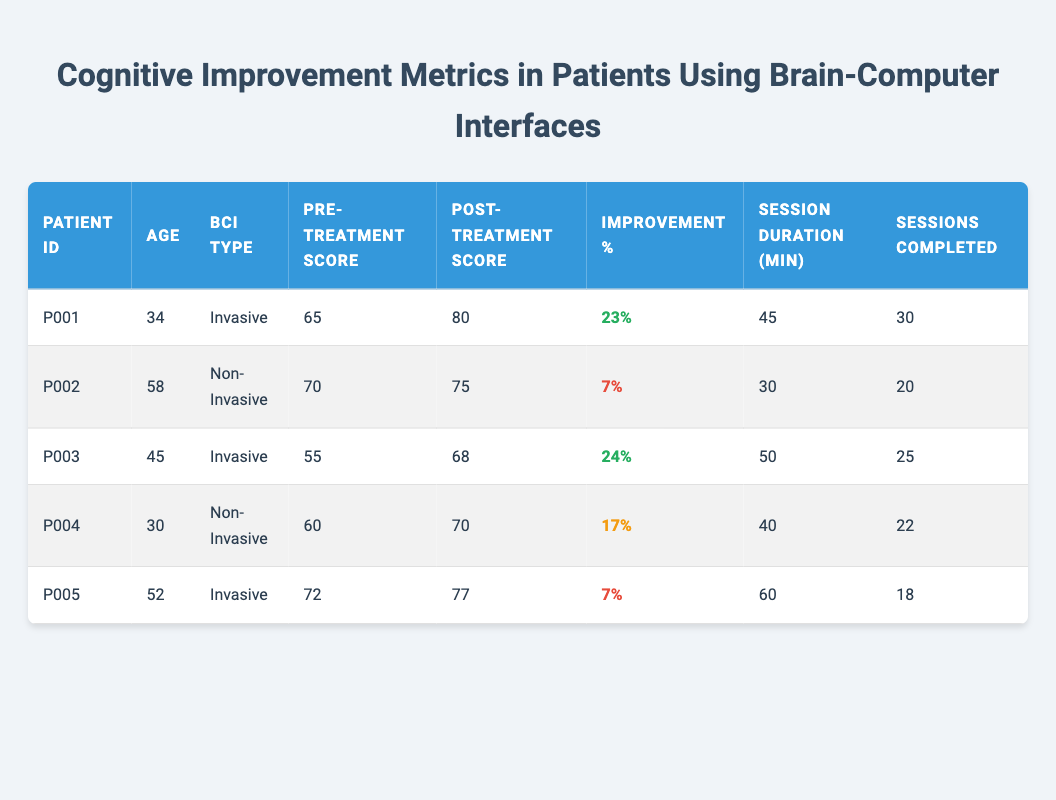What is the highest post-treatment cognitive score among the patients? To find the highest post-treatment cognitive score, we look at the "Post-Treatment Score" column and identify the maximum value. P001 has a score of 80, P002 has 75, P003 has 68, P004 has 70, and P005 has 77. The highest score is 80 from patient P001.
Answer: 80 What is the average age of all patients? To calculate the average age, we first sum the ages of all patients: 34 + 58 + 45 + 30 + 52 = 219. Then, we divide this sum by the number of patients, which is 5: 219/5 = 43.8.
Answer: 43.8 Did any patients show a cognitive improvement percentage of 20% or more after treatment? We check the "Improvement %" column for any values that are 20% or higher. P001 has 23%, P003 has 24%, while P002, P004, and P005 have lower percentages. Thus, P001 and P003 indeed showed an improvement of 20% or more.
Answer: Yes What is the total number of sessions completed by all patients? To find the total sessions completed, we sum the "Sessions Completed" column: P001 has 30, P002 has 20, P003 has 25, P004 has 22, and P005 has 18. Adding these gives us 30 + 20 + 25 + 22 + 18 = 115.
Answer: 115 Is there a patient who used a Non-Invasive BCI type and improved by more than 15%? We look at the entries with "BCI Type" as Non-Invasive, which are for P002 and P004. Their improvement percentages are 7% and 17%, respectively. Only P004 improved by more than 15%.
Answer: Yes What was the pre-treatment cognitive score of the youngest patient? We first identify the age of each patient and find that the youngest is P004 at age 30. Next, we check the "Pre-Treatment Score" for P004, which is 60.
Answer: 60 How much did the cognitive score improve for the oldest patient? The oldest patient is P002, aged 58. We calculate the improvement by subtracting the pre-treatment score (70) from the post-treatment score (75), which results in an improvement of 5.
Answer: 5 Which BCI type had the highest average improvement percentage? We calculate the average improvement for each BCI type. For Invasive: (23% + 24% + 7%)/3 = 18%. For Non-Invasive: (7% + 17%)/2 = 12%. The Invasive BCI type had a higher average improvement percentage.
Answer: Invasive BCI type What percentage improvement did the patient with the shortest session duration achieve? We look at the "Session Duration" column and find P002 with the shortest duration of 30 minutes. The improvement percentage for this patient is 7%.
Answer: 7% 